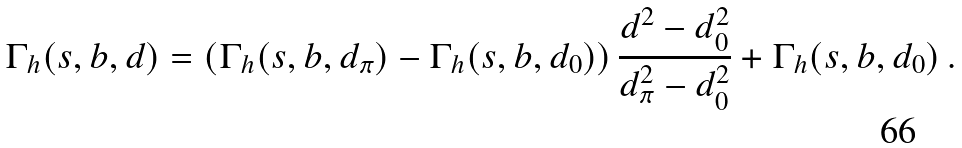Convert formula to latex. <formula><loc_0><loc_0><loc_500><loc_500>\Gamma _ { h } ( s , b , d ) = \left ( \Gamma _ { h } ( s , b , d _ { \pi } ) - \Gamma _ { h } ( s , b , d _ { 0 } ) \right ) \frac { d ^ { 2 } - d _ { 0 } ^ { 2 } } { d _ { \pi } ^ { 2 } - d _ { 0 } ^ { 2 } } + \Gamma _ { h } ( s , b , d _ { 0 } ) \, .</formula> 